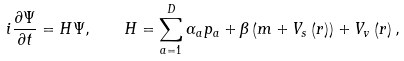<formula> <loc_0><loc_0><loc_500><loc_500>i \frac { \partial \Psi } { \partial { t } } = H \Psi , \quad H = \sum ^ { D } _ { a = 1 } \alpha _ { a } { p } _ { a } + \beta \left ( m + V _ { s } \left ( r \right ) \right ) + V _ { v } \left ( r \right ) ,</formula> 